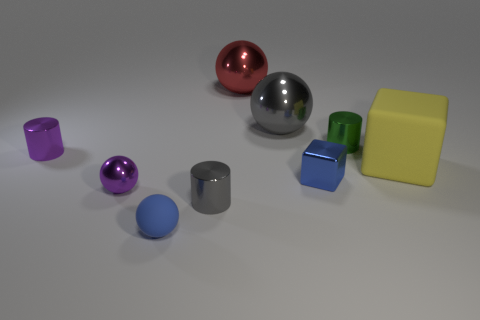What shapes are visible in the collection of objects? The collection shows a variety of geometric shapes including spheres, cylinders, a cube, and a rectangular prism. Do the different shapes indicate anything specific? The different shapes don't necessarily indicate anything specific but could be used to study geometry, light reflection, shading, and may serve as a reference for 3D modeling or artistic purposes. 